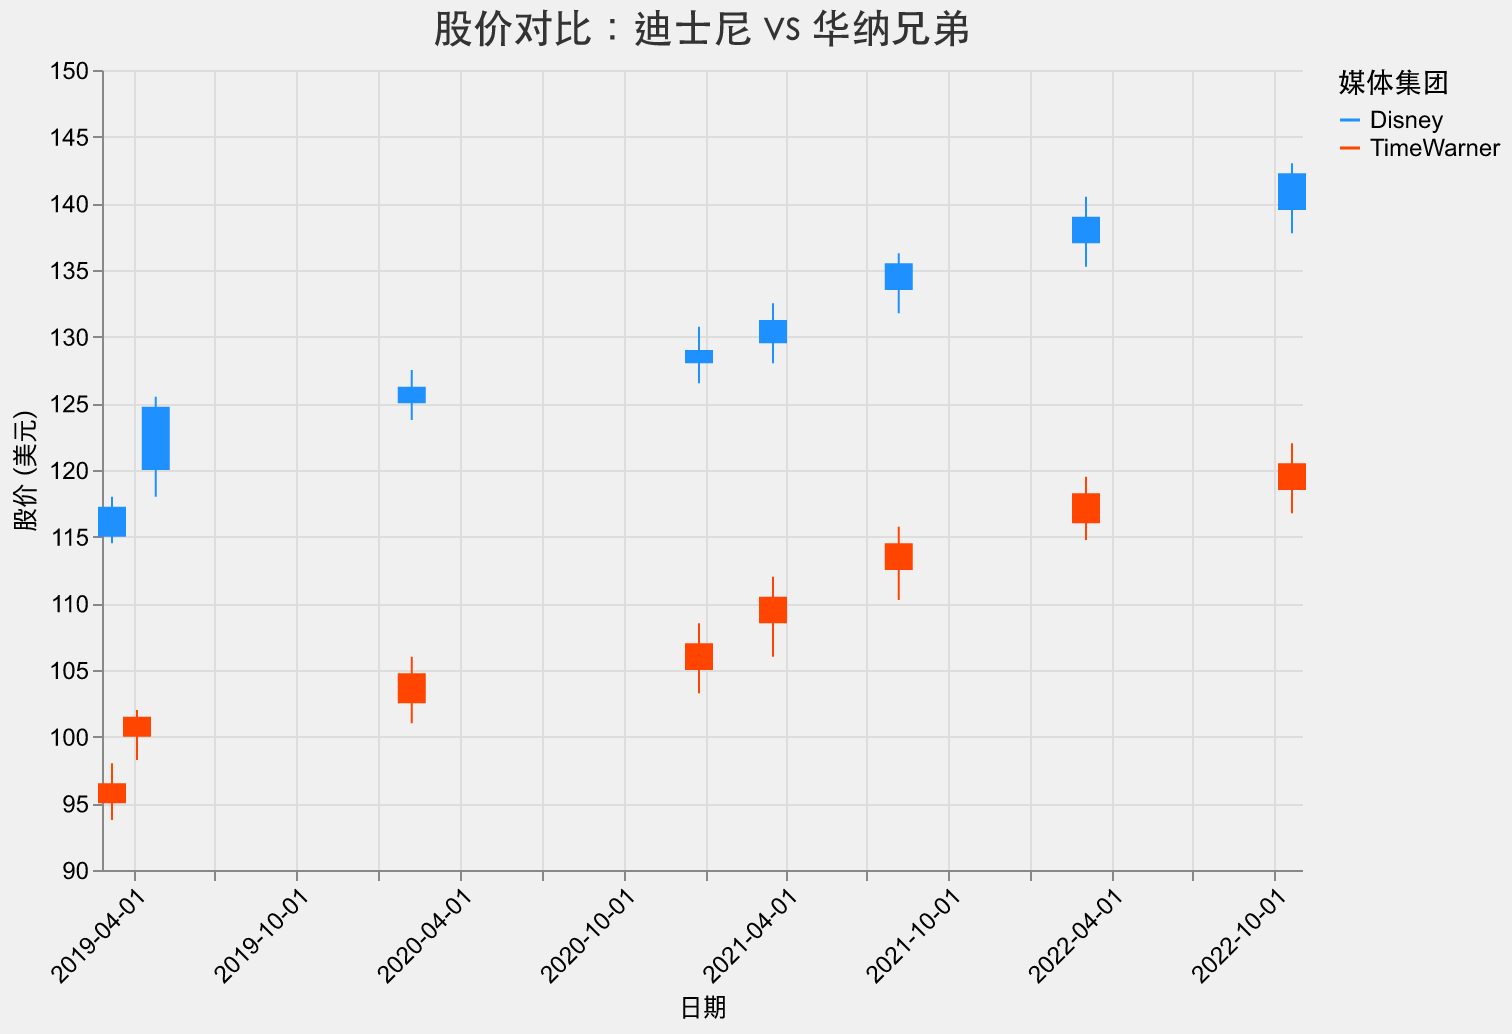What is the title of the figure? The title is located at the top of the figure, and it reads "股价对比：迪士尼 vs 华纳兄弟". This is written in Chinese and means "Stock Price Comparison: Disney vs Time Warner".
Answer: "股价对比：迪士尼 vs 华纳兄弟" What are the colors used to differentiate the two media conglomerates? The colors used to differentiate the media conglomerates are shown in the legend. Disney is represented by blue and TimeWarner by orange-red.
Answer: Blue and Orange-Red On which date did Disney reach its highest closing price? By observing the closing prices of Disney on different dates, we notice that on 2022-10-21, Disney had the highest closing price of 142.25 USD.
Answer: 2022-10-21 What is the range of the y-axis representing the stock prices? The y-axis shows the range of stock prices in dollars, with the minimum value starting at 90 and the maximum at 150 as shown by the scale on the axis.
Answer: 90 to 150 USD Which media conglomerate had a higher closing price on 2022-03-04, and what was the price? By comparing the closing prices of Disney and TimeWarner on 2022-03-04, Disney has a higher closing price of 139.00 USD, whereas TimeWarner's closing price was 118.25 USD.
Answer: Disney, 139.00 USD What was the difference in closing prices between Disney and TimeWarner on 2020-12-25? On 2020-12-25, Disney had a closing price of 129.00 USD, and TimeWarner had a closing price of 107.00 USD. The difference is 129.00 - 107.00 = 22.00 USD.
Answer: 22.00 USD Which company had the largest increase in stock price on 2020-02-07? To determine the largest increase, we look at the difference between the closing price and the opening price. For Disney, it's 126.25 - 125.00 = 1.25 USD. For TimeWarner, it's 104.75 - 102.50 = 2.25 USD. TimeWarner had the larger increase.
Answer: TimeWarner Between the two dates 2021-03-18 and 2021-08-06, how much did Disney’s closing price change? Disney's closing price on 2021-03-18 was 131.25 USD and on 2021-08-06 it was 135.50 USD. The change is 135.50 - 131.25 = 4.25 USD.
Answer: 4.25 USD What were the opening and closing stock prices for TimeWarner on 2022-10-21? Referencing the stock data for 2022-10-21, TimeWarner opened at 118.50 USD and closed at 120.50 USD.
Answer: Open: 118.50 USD, Close: 120.50 USD 